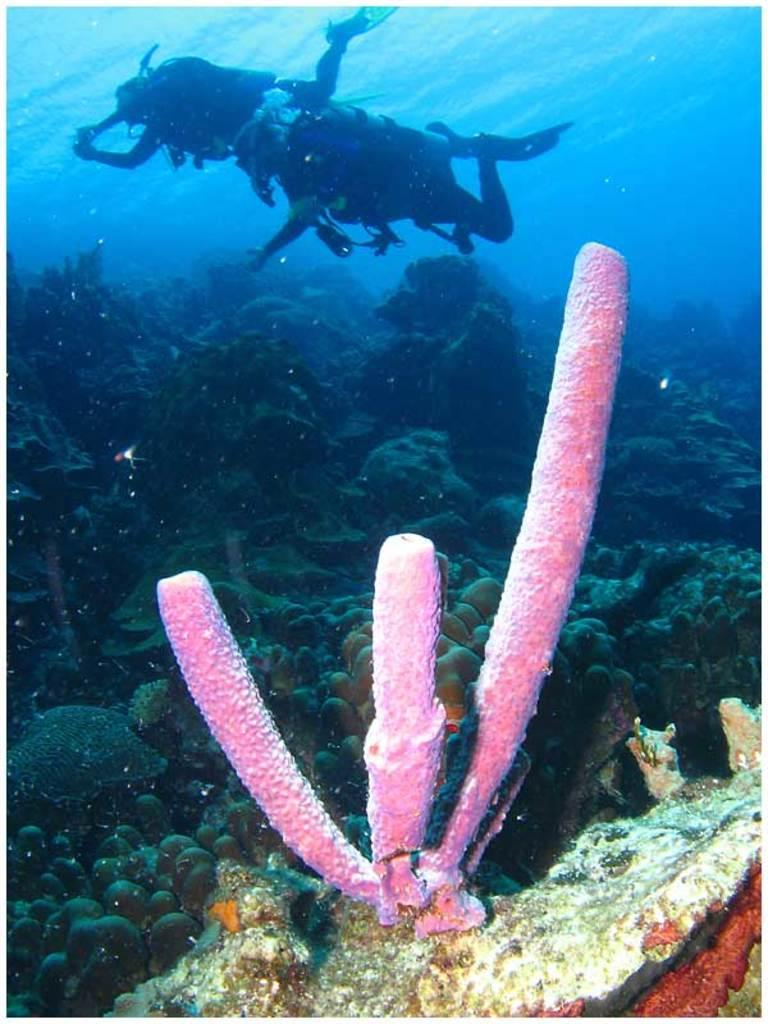What type of plant can be seen in the image? There is a plant in the image, and it is pink in color. What other objects are present in the image? There are rocks and many aquatic plants in the image. What is the color of the water in the image? The water in the image is blue in color. What type of organization does the father belong to in the image? There is no father or organization present in the image. 